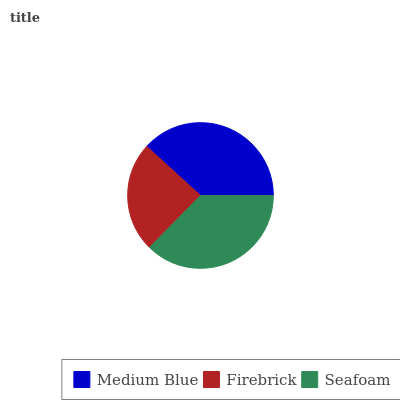Is Firebrick the minimum?
Answer yes or no. Yes. Is Medium Blue the maximum?
Answer yes or no. Yes. Is Seafoam the minimum?
Answer yes or no. No. Is Seafoam the maximum?
Answer yes or no. No. Is Seafoam greater than Firebrick?
Answer yes or no. Yes. Is Firebrick less than Seafoam?
Answer yes or no. Yes. Is Firebrick greater than Seafoam?
Answer yes or no. No. Is Seafoam less than Firebrick?
Answer yes or no. No. Is Seafoam the high median?
Answer yes or no. Yes. Is Seafoam the low median?
Answer yes or no. Yes. Is Medium Blue the high median?
Answer yes or no. No. Is Firebrick the low median?
Answer yes or no. No. 